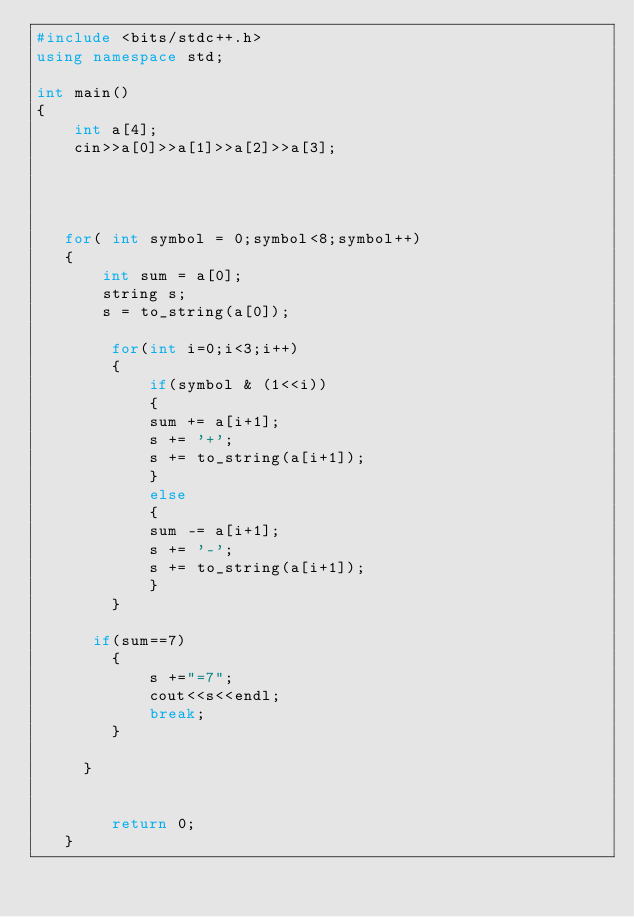<code> <loc_0><loc_0><loc_500><loc_500><_C++_>#include <bits/stdc++.h>
using namespace std;

int main()
{
    int a[4];
    cin>>a[0]>>a[1]>>a[2]>>a[3];
   
   

  
   for( int symbol = 0;symbol<8;symbol++)
   {
       int sum = a[0];
       string s;
       s = to_string(a[0]);
       
        for(int i=0;i<3;i++)
        {
            if(symbol & (1<<i))
            {
            sum += a[i+1];
            s += '+';
            s += to_string(a[i+1]);
            }
            else
            {
            sum -= a[i+1];
            s += '-';
            s += to_string(a[i+1]);
            }
        }
     
      if(sum==7)
        {  
            s +="=7";
            cout<<s<<endl;
            break;
        }
     
     }
   
      
        return 0;
   }
    
</code> 